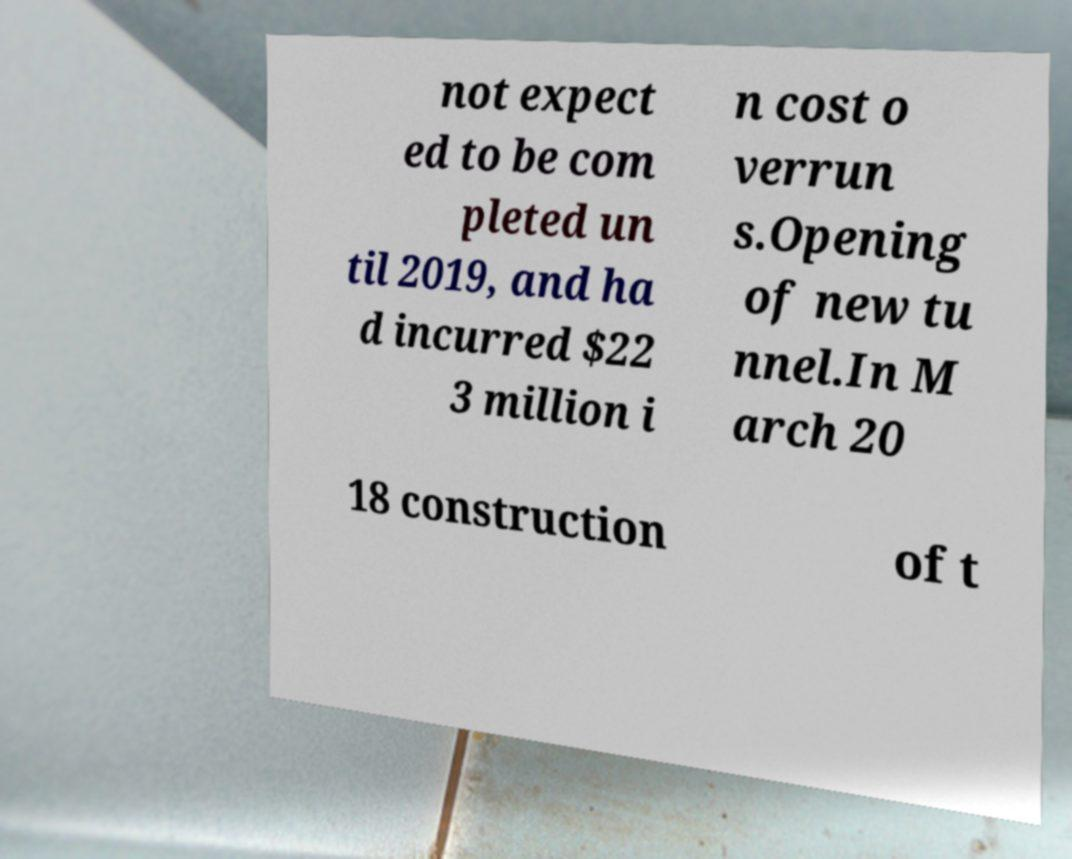What messages or text are displayed in this image? I need them in a readable, typed format. not expect ed to be com pleted un til 2019, and ha d incurred $22 3 million i n cost o verrun s.Opening of new tu nnel.In M arch 20 18 construction of t 